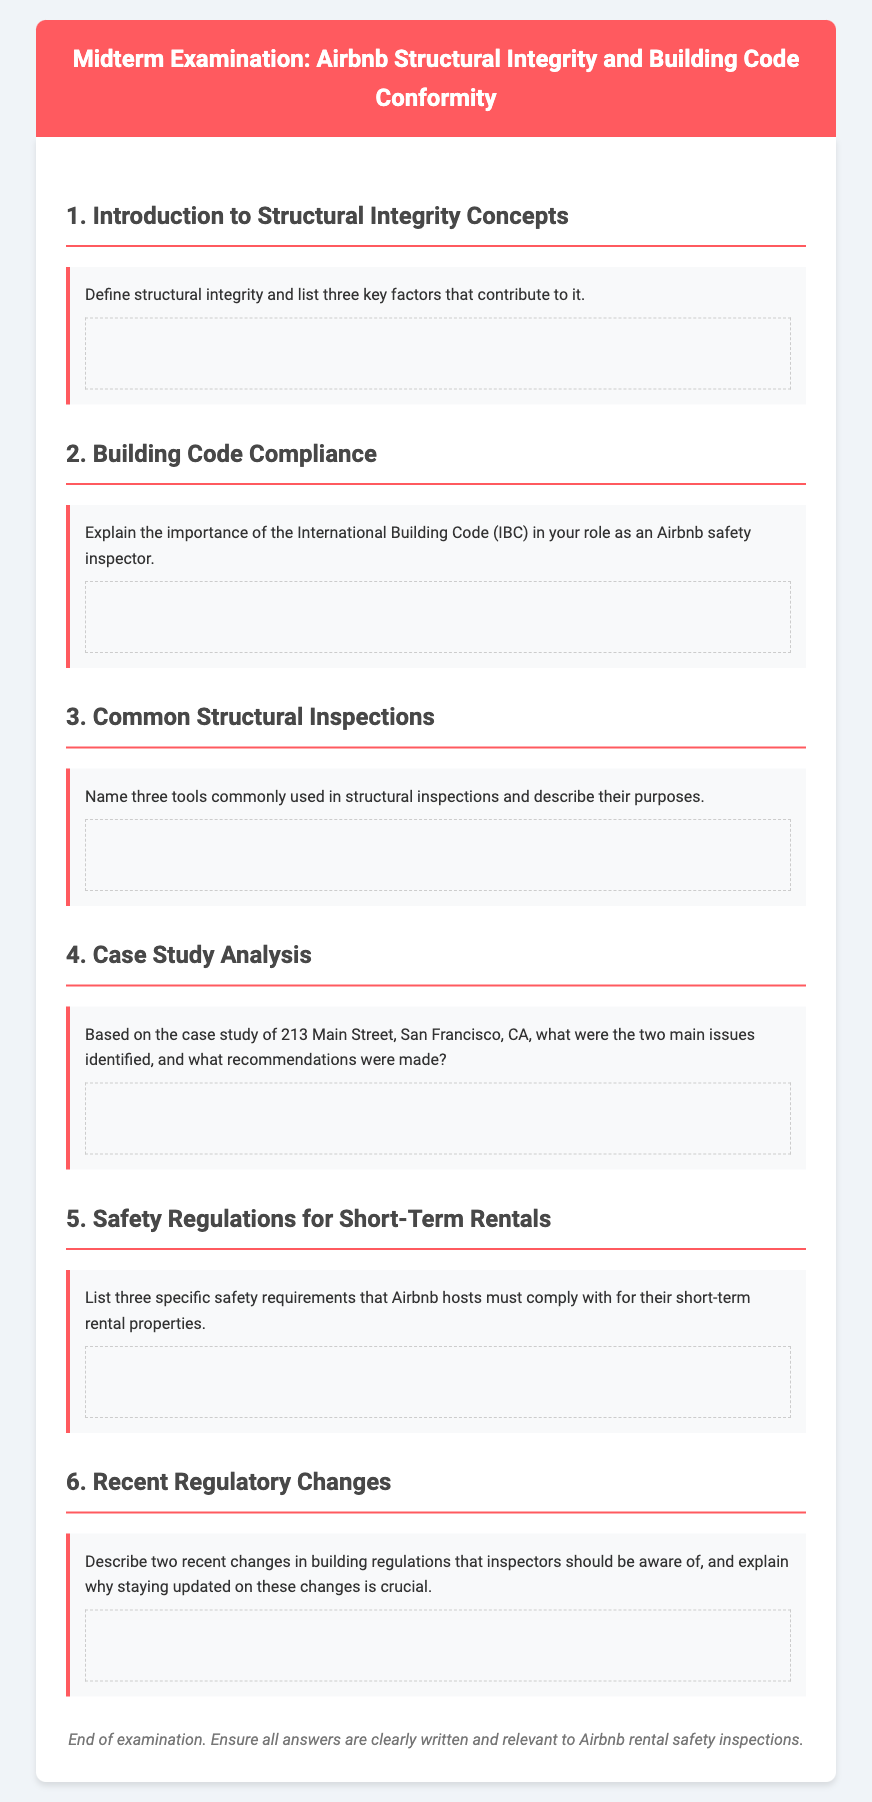What is the title of the exam? The title of the exam is provided in the header of the document.
Answer: Airbnb Structural Integrity and Building Code Conformity Exam What is the first topic covered in the exam? The first topic is indicated by the numbered heading in the exam content.
Answer: Introduction to Structural Integrity Concepts How many questions are there in total? The total number of questions can be counted from the main sections listed in the document.
Answer: Six Name one tool commonly used in structural inspections. This information is requested in the section about common structural inspections.
Answer: Three tools What is the purpose of the International Building Code (IBC)? This is explained in the section discussing building code compliance in the exam.
Answer: Importance in safety inspections What is a recent regulatory change mentioned? The request is to identify two recent changes noted in the exam.
Answer: Changes in building regulations What is the safety requirement mentioned for Airbnb hosts? This is a specific guideline mentioned under safety regulations for short-term rentals.
Answer: Three specific safety requirements Who is the intended audience for this examination? The audience can be inferred from the content and context of the document.
Answer: Airbnb safety inspectors What is the background color of the exam header? The background color is outlined in the CSS styling for the header section.
Answer: #ff5a5f 